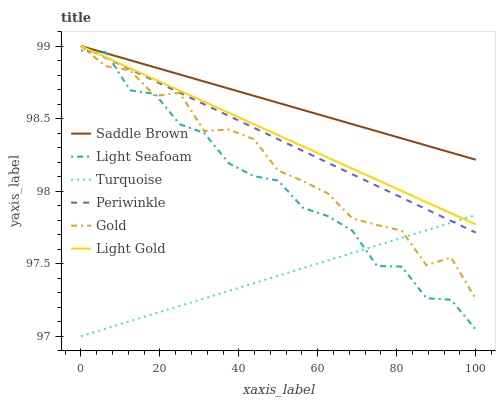Does Turquoise have the minimum area under the curve?
Answer yes or no. Yes. Does Saddle Brown have the maximum area under the curve?
Answer yes or no. Yes. Does Gold have the minimum area under the curve?
Answer yes or no. No. Does Gold have the maximum area under the curve?
Answer yes or no. No. Is Light Gold the smoothest?
Answer yes or no. Yes. Is Light Seafoam the roughest?
Answer yes or no. Yes. Is Gold the smoothest?
Answer yes or no. No. Is Gold the roughest?
Answer yes or no. No. Does Turquoise have the lowest value?
Answer yes or no. Yes. Does Gold have the lowest value?
Answer yes or no. No. Does Saddle Brown have the highest value?
Answer yes or no. Yes. Does Light Seafoam have the highest value?
Answer yes or no. No. Is Turquoise less than Saddle Brown?
Answer yes or no. Yes. Is Saddle Brown greater than Turquoise?
Answer yes or no. Yes. Does Light Gold intersect Gold?
Answer yes or no. Yes. Is Light Gold less than Gold?
Answer yes or no. No. Is Light Gold greater than Gold?
Answer yes or no. No. Does Turquoise intersect Saddle Brown?
Answer yes or no. No. 